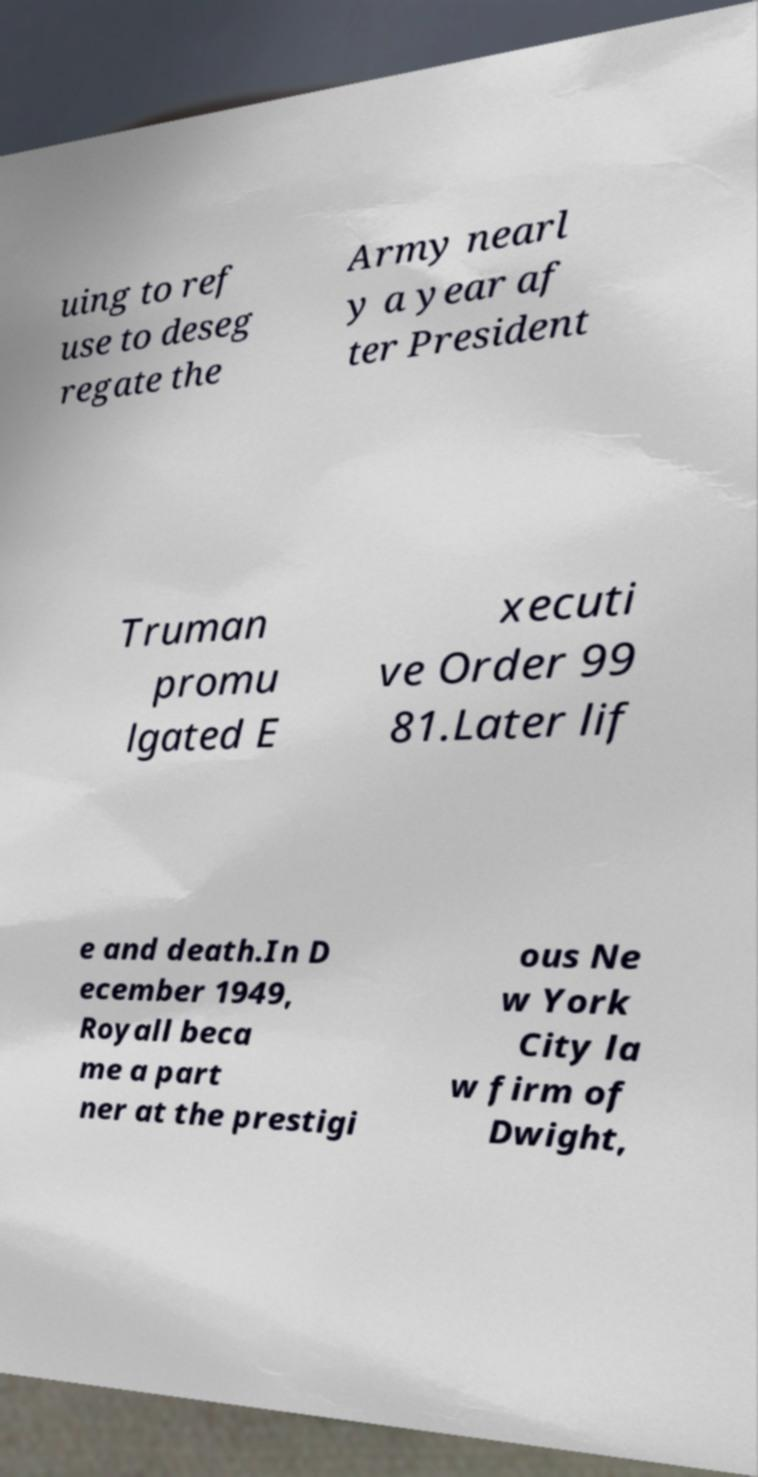What messages or text are displayed in this image? I need them in a readable, typed format. uing to ref use to deseg regate the Army nearl y a year af ter President Truman promu lgated E xecuti ve Order 99 81.Later lif e and death.In D ecember 1949, Royall beca me a part ner at the prestigi ous Ne w York City la w firm of Dwight, 